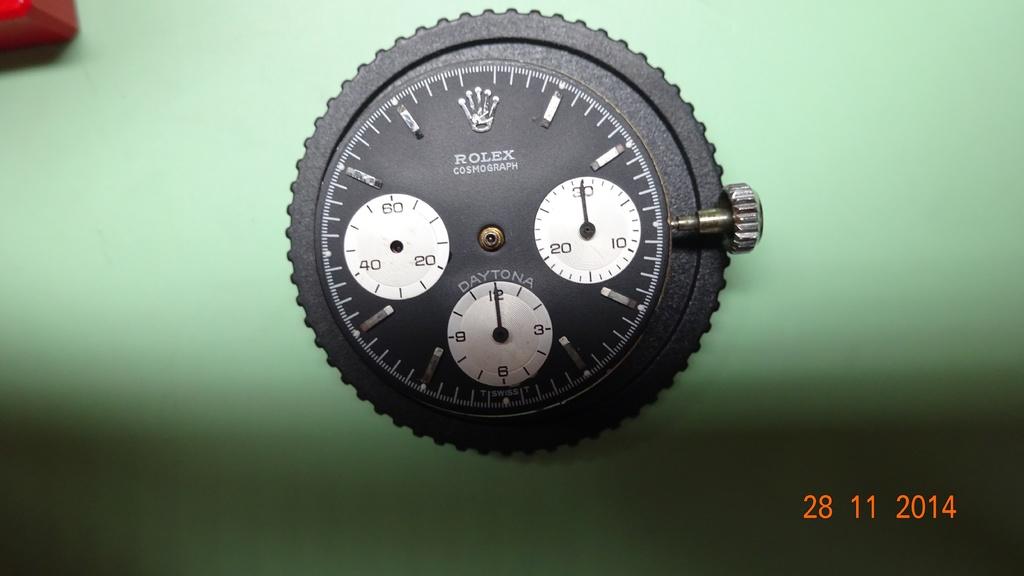What famous watch brand is shown here?
Offer a very short reply. Rolex. What is the date on the bottom right?
Provide a succinct answer. 28 11 2014. 